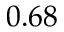<formula> <loc_0><loc_0><loc_500><loc_500>0 . 6 8</formula> 